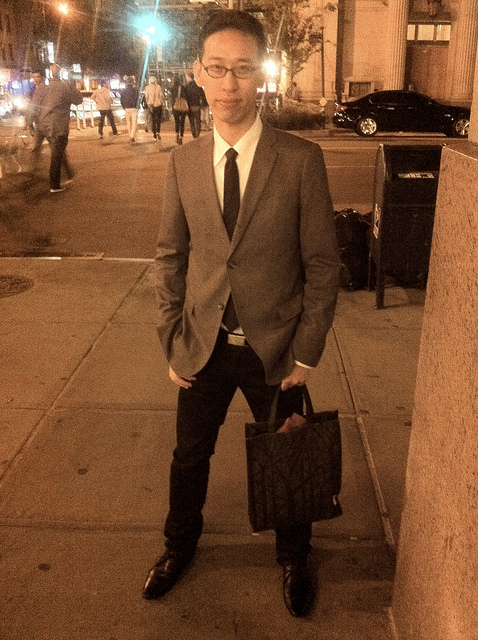<image>What picture is on the bag? I don't know what picture is on the bag. It could be stripes, trees, or a flower. What picture is on the bag? I am not sure what picture is on the bag. It can be seen stripes, trees, flower or nothing. 